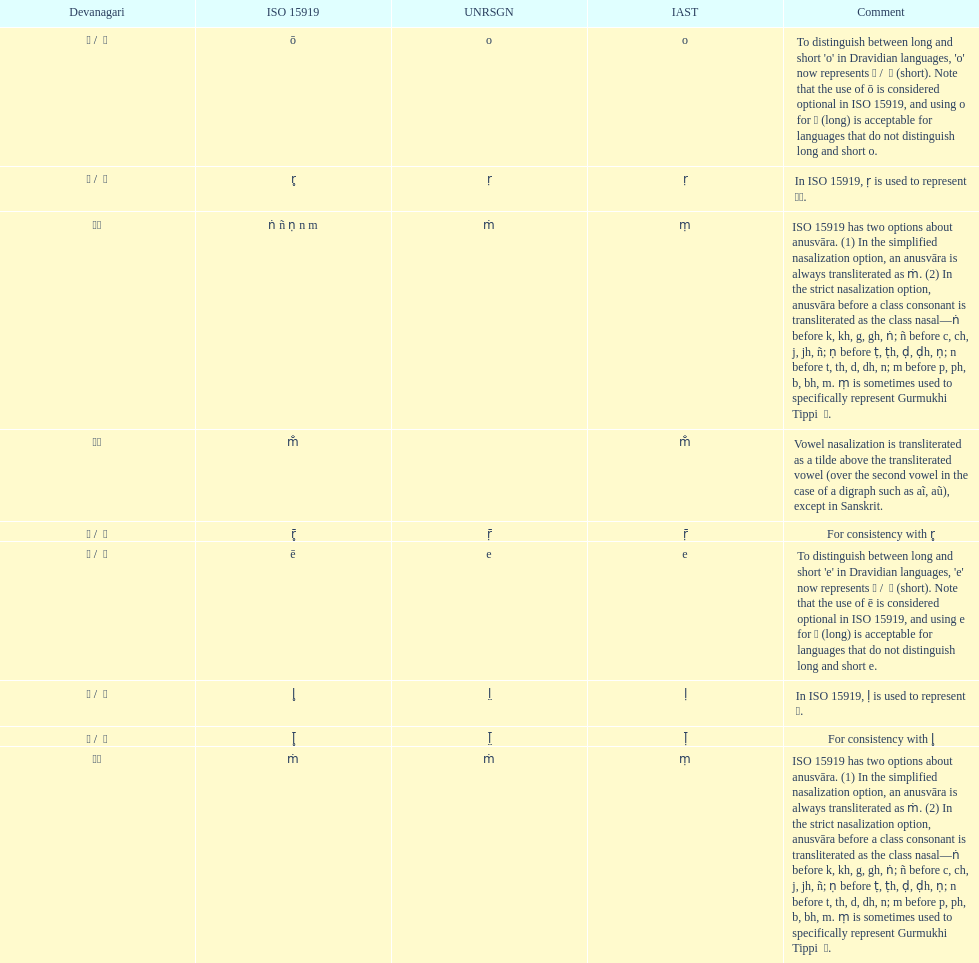Which devanagaria means the same as this iast letter: o? ओ / ो. 